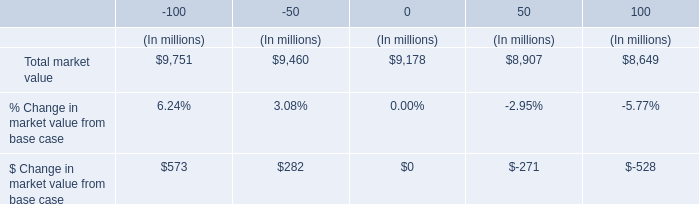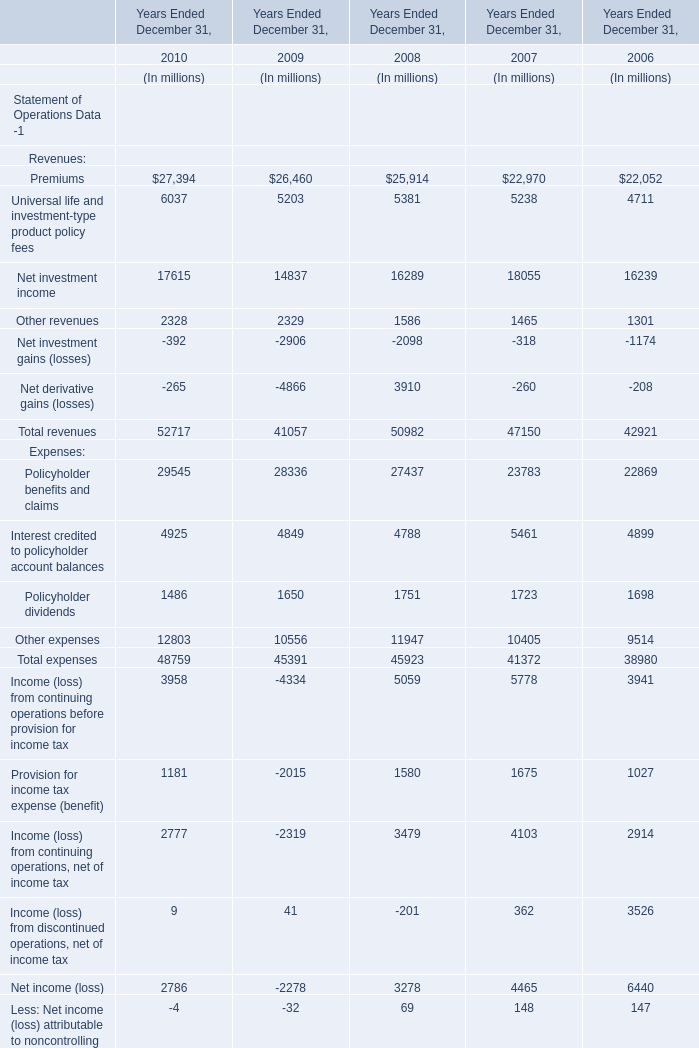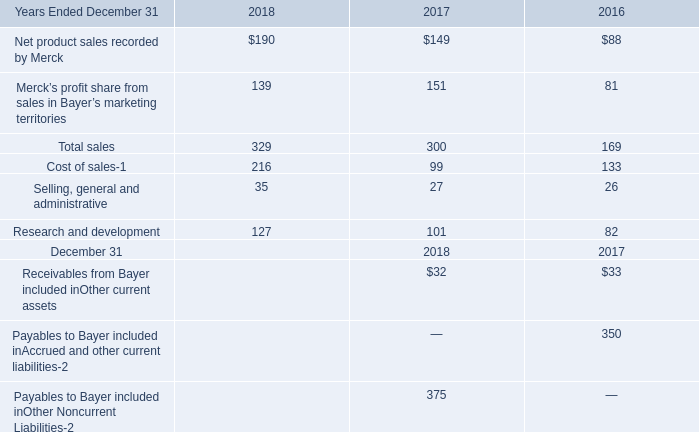What will total revenue reach in 2011 if it continues to grow at its current rate? (in million) 
Computations: ((((52717 - 41057) / 41057) + 1) * 52717)
Answer: 67688.38661. 